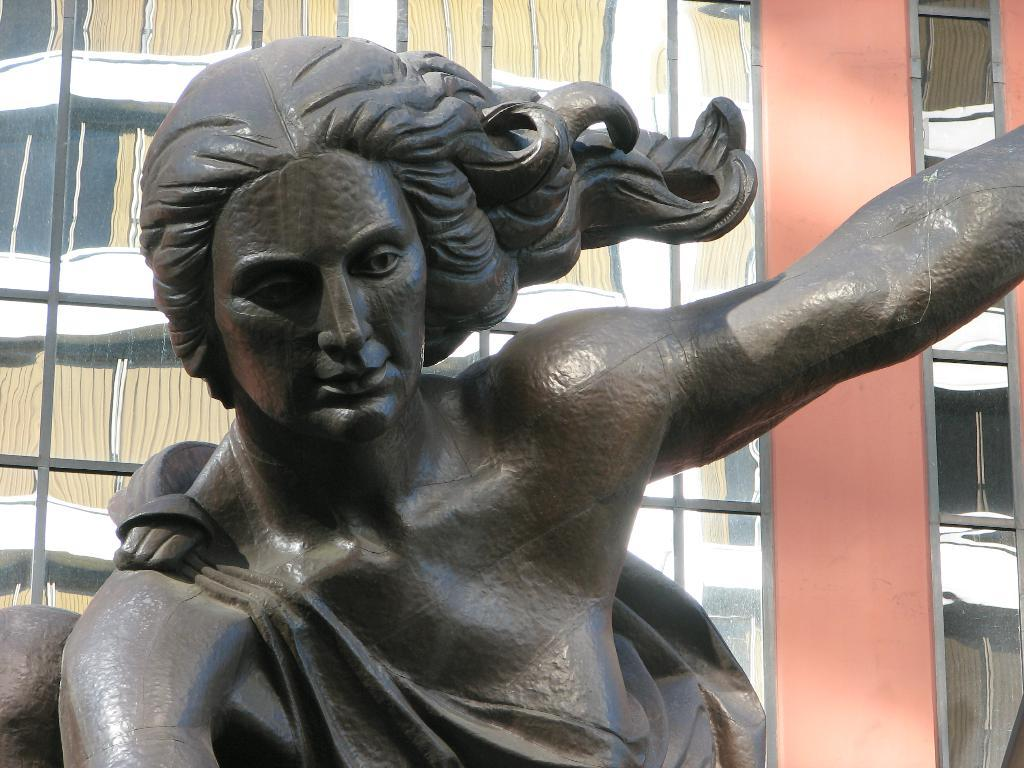What is the main subject of the image? There is a sculpture of a person in the image. What is located behind the sculpture? There is a glass window behind the sculpture. What can be seen through the glass window? Windows of a building are visible outside the glass window. What type of summer activity is the sculpture participating in outside the jail? There is no jail or summer activity present in the image; it features a sculpture of a person with a glass window behind it and windows of a building visible outside. 